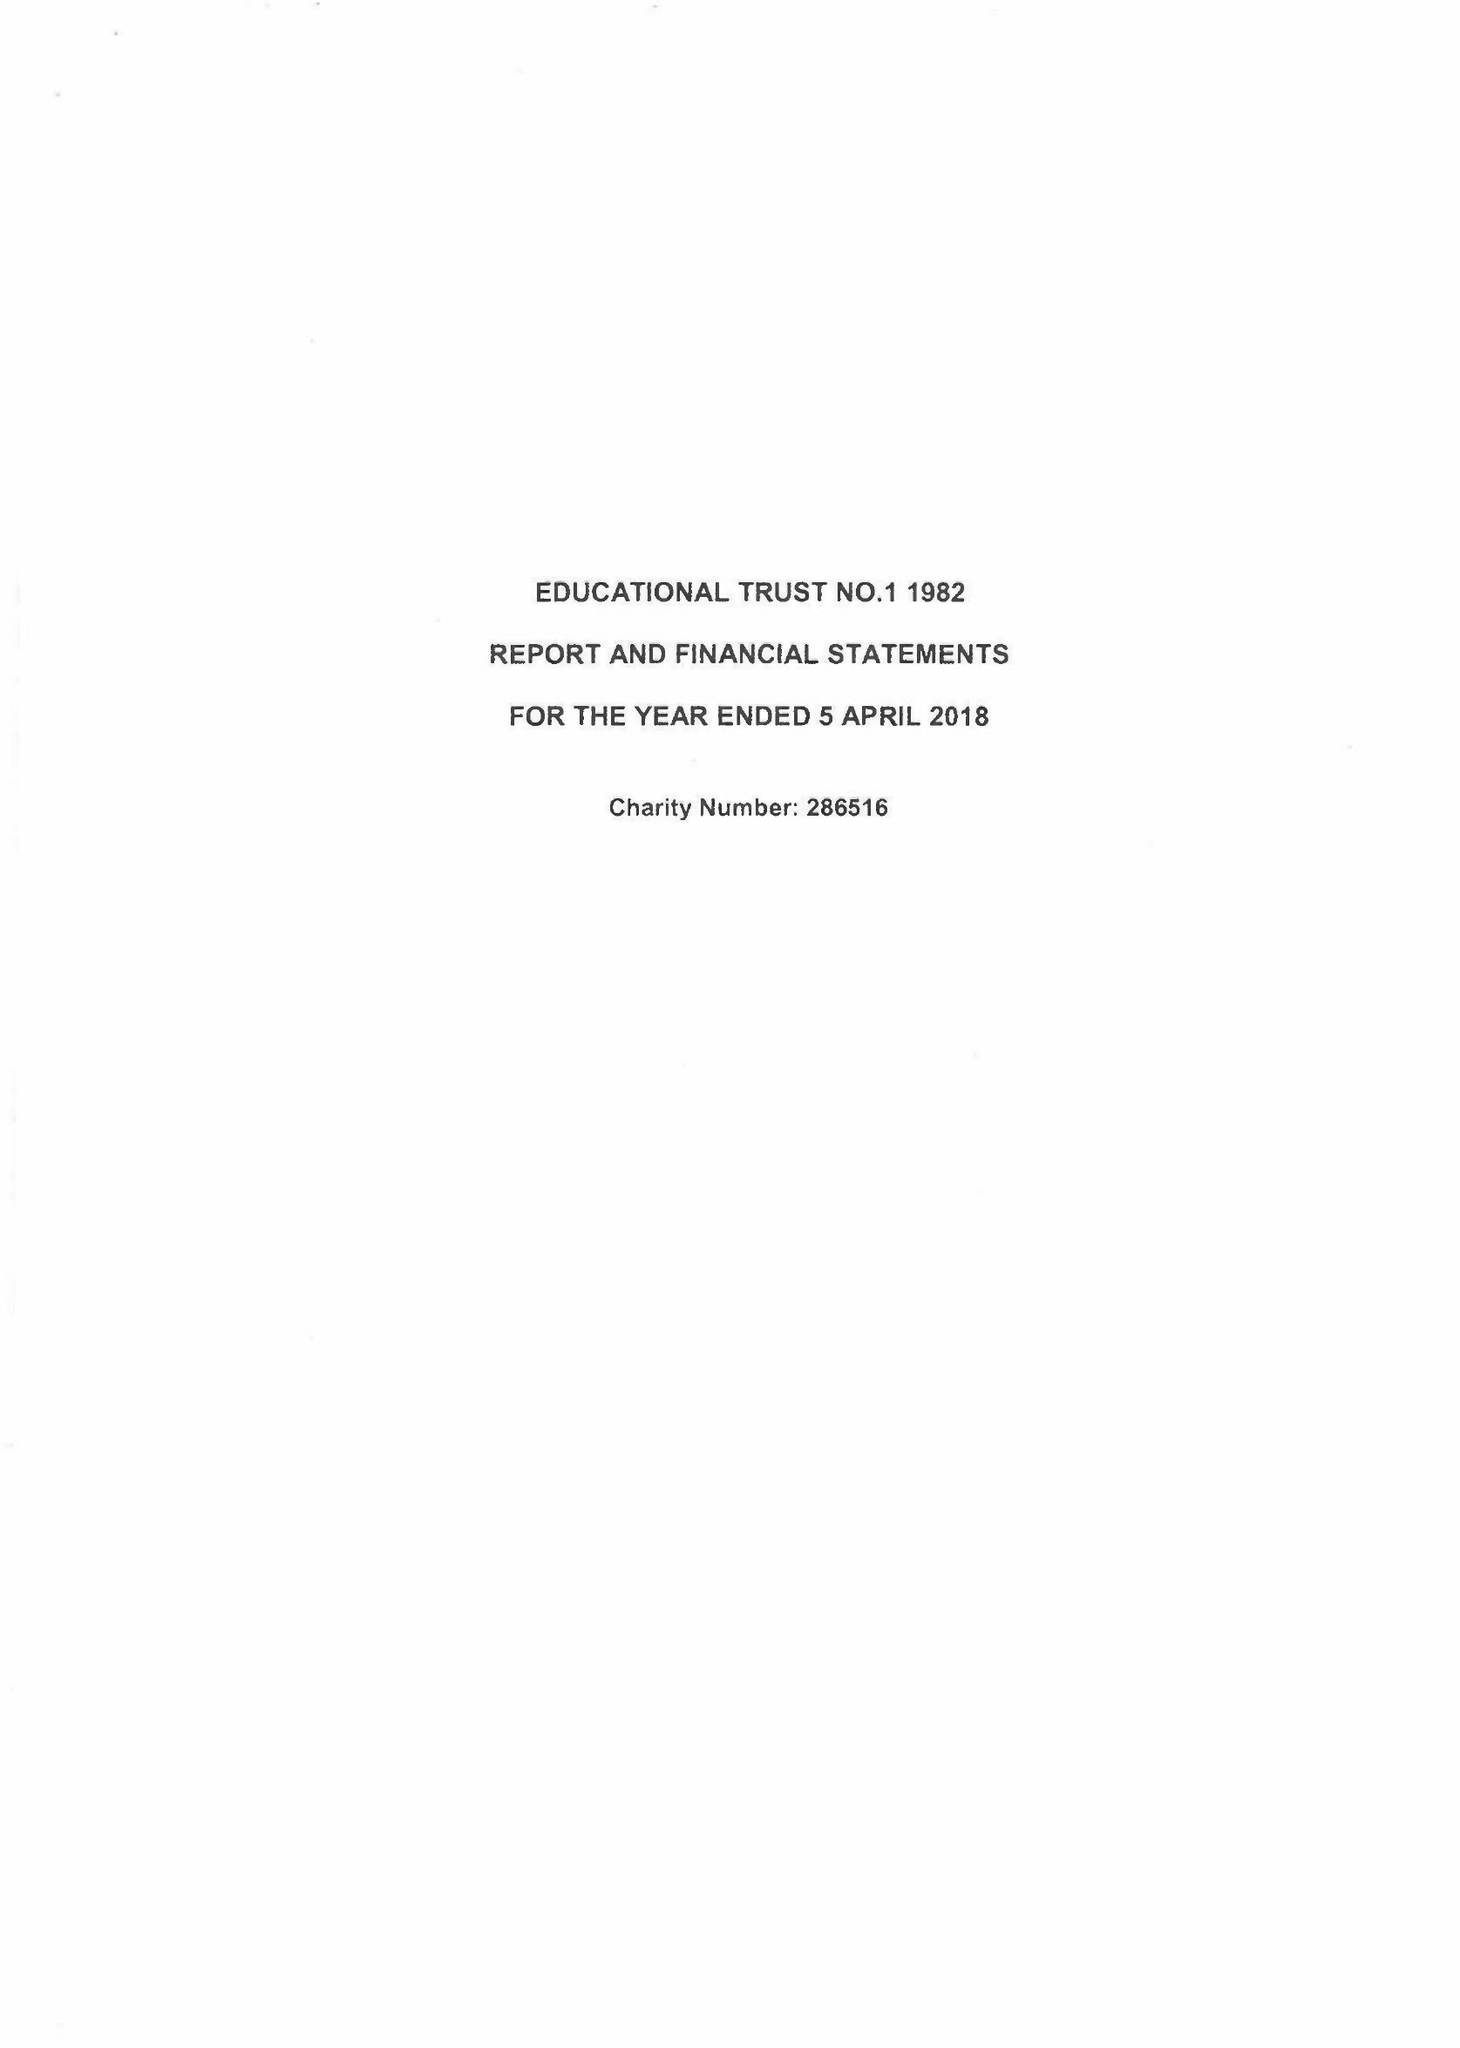What is the value for the report_date?
Answer the question using a single word or phrase. 2018-04-05 